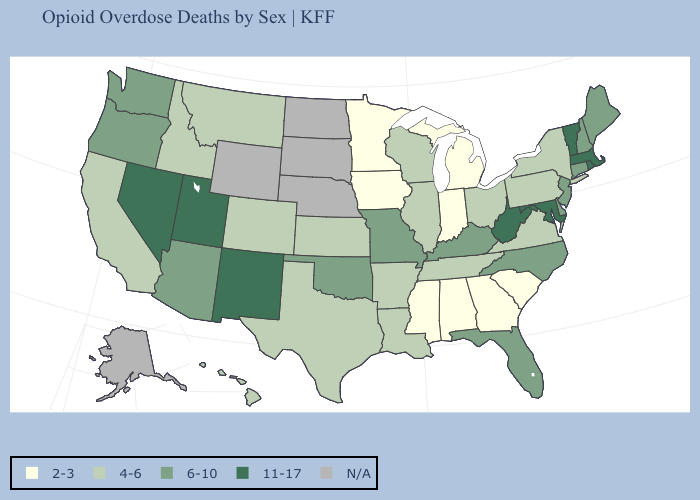Name the states that have a value in the range N/A?
Answer briefly. Alaska, Nebraska, North Dakota, South Dakota, Wyoming. What is the value of Illinois?
Be succinct. 4-6. What is the value of Wyoming?
Be succinct. N/A. How many symbols are there in the legend?
Give a very brief answer. 5. What is the highest value in the West ?
Answer briefly. 11-17. What is the value of Maine?
Short answer required. 6-10. What is the value of New Mexico?
Quick response, please. 11-17. Which states have the lowest value in the West?
Be succinct. California, Colorado, Hawaii, Idaho, Montana. What is the lowest value in the USA?
Give a very brief answer. 2-3. Does the first symbol in the legend represent the smallest category?
Give a very brief answer. Yes. Does Missouri have the highest value in the MidWest?
Keep it brief. Yes. What is the value of Oregon?
Answer briefly. 6-10. What is the highest value in states that border Oregon?
Quick response, please. 11-17. What is the highest value in the USA?
Be succinct. 11-17. Among the states that border South Carolina , which have the lowest value?
Concise answer only. Georgia. 